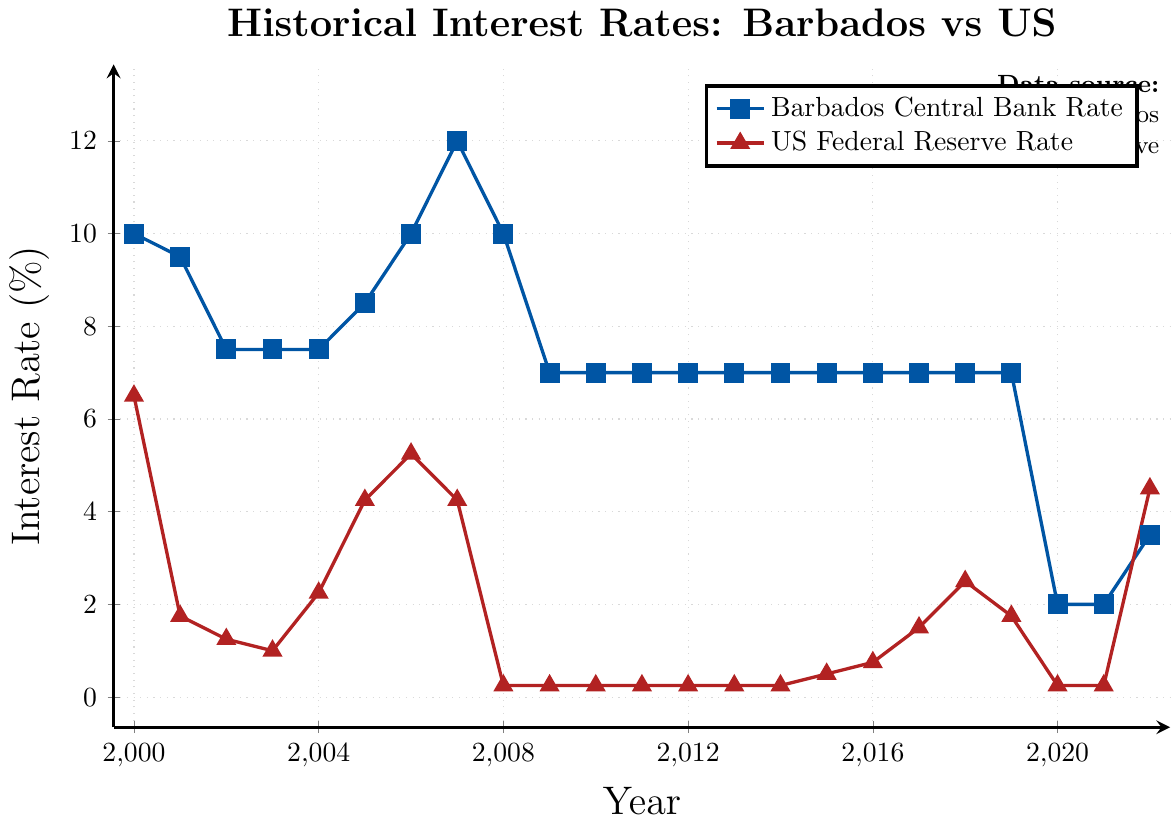Which year had the highest interest rate set by the Barbados Central Bank, and what was the rate? The figure shows that the highest interest rate set by the Barbados Central Bank was in 2007 with a rate of 12%.
Answer: 2007, 12% What was the difference in interest rates between Barbados and the US in 2008? In 2008, the Barbados Central Bank's rate was 10%, while the US Federal Reserve's rate was 0.25%. The difference is 10 - 0.25 = 9.75%.
Answer: 9.75% How did the US Federal Reserve rate compare to the Barbados Central Bank rate in 2015? The chart shows that in 2015, the Barbados Central Bank rate was 7%, and the US Federal Reserve rate was 0.50%. The Barbados rate was higher.
Answer: The Barbados rate was higher By how much did the Barbados Central Bank rate drop from 2019 to 2020? In 2019, the rate was 7%, and in 2020, it dropped to 2%. The difference is 7 - 2 = 5%.
Answer: 5% What is the average interest rate set by the Barbados Central Bank from 2000 to 2022? Adding the rates from 2000 to 2022 and then dividing by the number of years (23) gives: (10+9.5+7.5+7.5+7.5+8.5+10+12+10+7+7+7+7+7+7+7+7+7+7+2+2+3.5)/23 = 7 terms: ((10 + 9.5 + 7.5 + 7.5 + 7.5 + 8.5 + 10 + 12 + 10 + 7 + 7 + 7 + 7 + 7 + 7 + 7 + 7 + 7 + 7 + 2 + 2 + 3.5) / 23) = 6.739%.
Answer: 6.739% What trend can be observed in the Barbados Central Bank rate from 2000 to 2022? The trend shows a high starting point in 2000, followed by a decline and stabilizing around 7% for several years before a significant drop in 2020, and then a slight rise until 2022.
Answer: High to stable to drop to slight rise In what years did both the Barbados Central Bank rate and the US Federal Reserve rate remain constant, and what were those rates? Both the Barbados Central Bank rate and the US Federal Reserve rate remained constant from 2010 to 2014. The rates were 7% for Barbados and 0.25% for the US.
Answer: 2010-2014, 7% and 0.25% What was the percentage increase in the US Federal Reserve rate from 2021 to 2022? The US Federal Reserve rate in 2021 was 0.25%, and in 2022, it was 4.50%. The percentage increase is ((4.50 - 0.25) / 0.25) * 100 = 1700%.
Answer: 1700% Which country had a higher rate in 2005, and by how much? In 2005, the Barbados Central Bank rate was 8.50%, and the US Federal Reserve rate was 4.25%. Barbados had a higher rate by 8.50 - 4.25 = 4.25%.
Answer: Barbados, 4.25% During which period did the Barbados Central Bank rate remain constant the longest, and what was that rate? The Barbados Central Bank rate remained constant at 7% from 2009 to 2019, which is the longest period of constancy at 11 years.
Answer: 2009-2019, 7% 